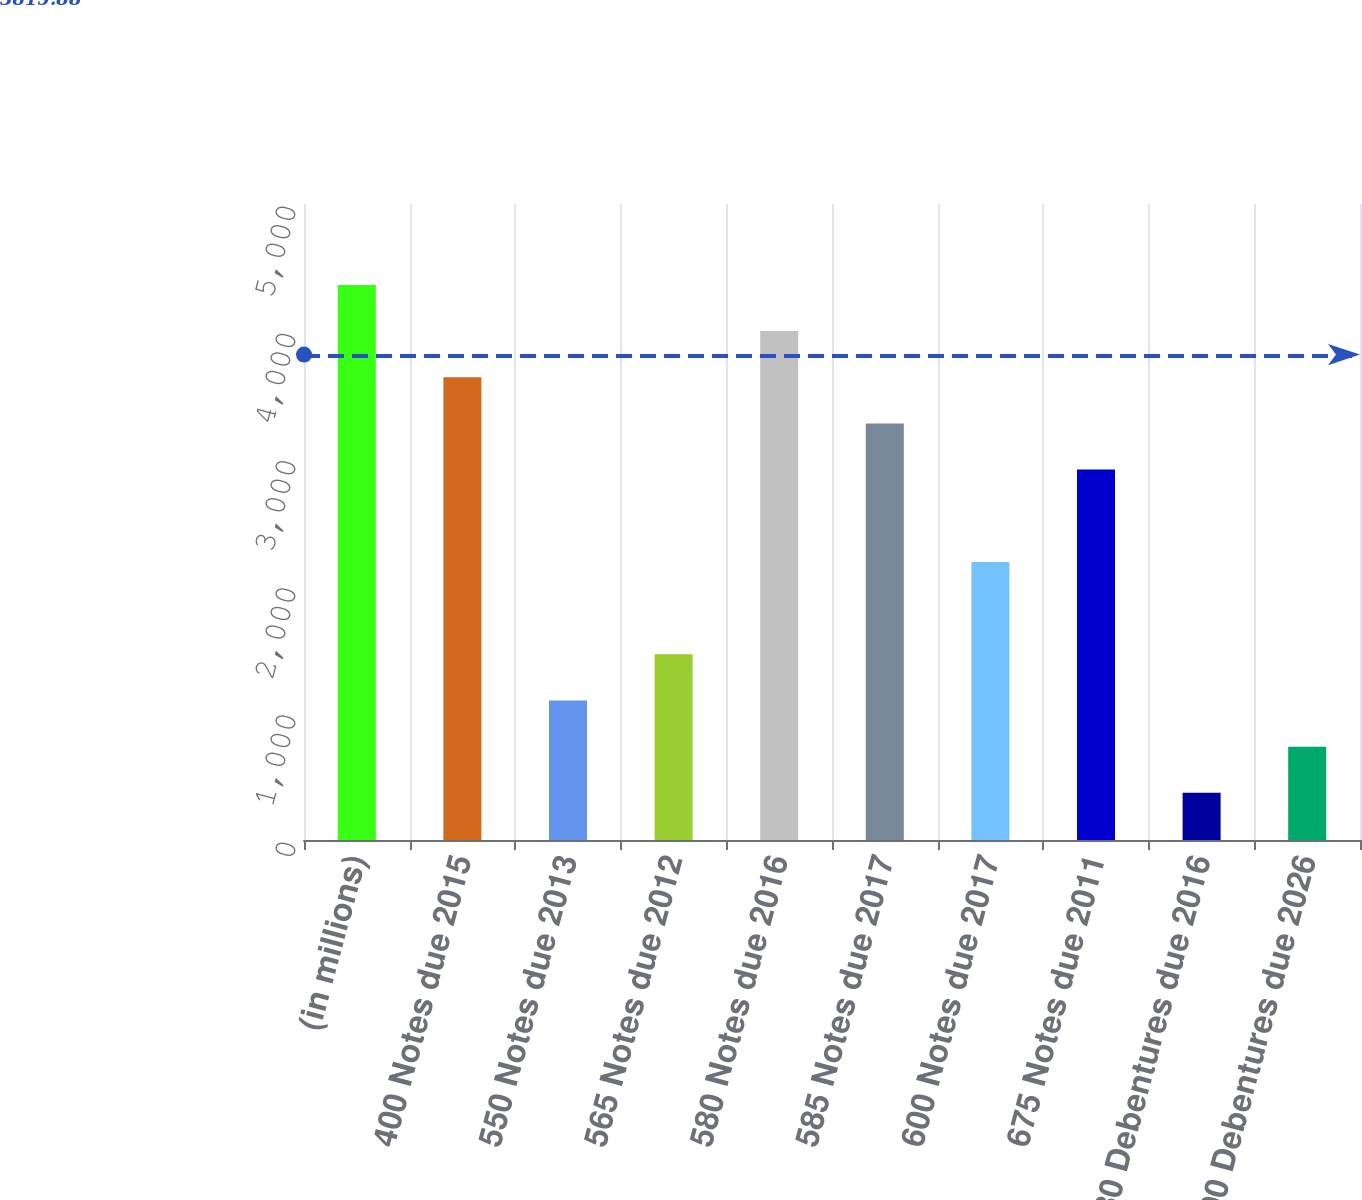Convert chart to OTSL. <chart><loc_0><loc_0><loc_500><loc_500><bar_chart><fcel>(in millions)<fcel>400 Notes due 2015<fcel>550 Notes due 2013<fcel>565 Notes due 2012<fcel>580 Notes due 2016<fcel>585 Notes due 2017<fcel>600 Notes due 2017<fcel>675 Notes due 2011<fcel>780 Debentures due 2016<fcel>700 Debentures due 2026<nl><fcel>4363.8<fcel>3637.8<fcel>1096.8<fcel>1459.8<fcel>4000.8<fcel>3274.8<fcel>2185.8<fcel>2911.8<fcel>370.8<fcel>733.8<nl></chart> 